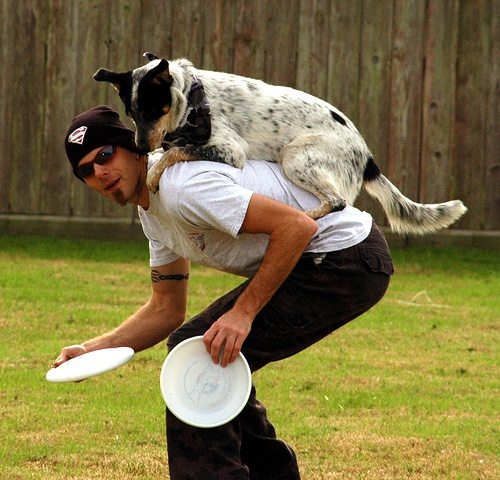Describe the objects in this image and their specific colors. I can see people in olive, black, lightgray, maroon, and brown tones, dog in olive, black, darkgray, ivory, and beige tones, frisbee in olive, lightgray, beige, and darkgray tones, and frisbee in gray, white, beige, and olive tones in this image. 